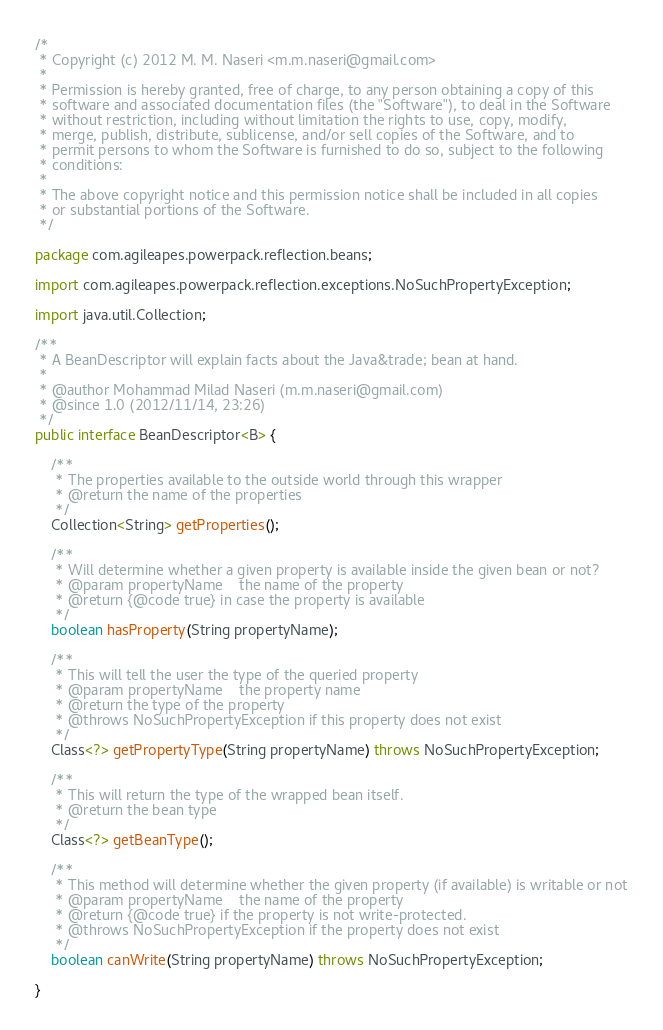Convert code to text. <code><loc_0><loc_0><loc_500><loc_500><_Java_>/*
 * Copyright (c) 2012 M. M. Naseri <m.m.naseri@gmail.com>
 *
 * Permission is hereby granted, free of charge, to any person obtaining a copy of this
 * software and associated documentation files (the "Software"), to deal in the Software
 * without restriction, including without limitation the rights to use, copy, modify,
 * merge, publish, distribute, sublicense, and/or sell copies of the Software, and to
 * permit persons to whom the Software is furnished to do so, subject to the following
 * conditions:
 *
 * The above copyright notice and this permission notice shall be included in all copies
 * or substantial portions of the Software.
 */

package com.agileapes.powerpack.reflection.beans;

import com.agileapes.powerpack.reflection.exceptions.NoSuchPropertyException;

import java.util.Collection;

/**
 * A BeanDescriptor will explain facts about the Java&trade; bean at hand.
 *
 * @author Mohammad Milad Naseri (m.m.naseri@gmail.com)
 * @since 1.0 (2012/11/14, 23:26)
 */
public interface BeanDescriptor<B> {

    /**
     * The properties available to the outside world through this wrapper
     * @return the name of the properties
     */
    Collection<String> getProperties();

    /**
     * Will determine whether a given property is available inside the given bean or not?
     * @param propertyName    the name of the property
     * @return {@code true} in case the property is available
     */
    boolean hasProperty(String propertyName);

    /**
     * This will tell the user the type of the queried property
     * @param propertyName    the property name
     * @return the type of the property
     * @throws NoSuchPropertyException if this property does not exist
     */
    Class<?> getPropertyType(String propertyName) throws NoSuchPropertyException;

    /**
     * This will return the type of the wrapped bean itself.
     * @return the bean type
     */
    Class<?> getBeanType();

    /**
     * This method will determine whether the given property (if available) is writable or not
     * @param propertyName    the name of the property
     * @return {@code true} if the property is not write-protected.
     * @throws NoSuchPropertyException if the property does not exist
     */
    boolean canWrite(String propertyName) throws NoSuchPropertyException;

}
</code> 